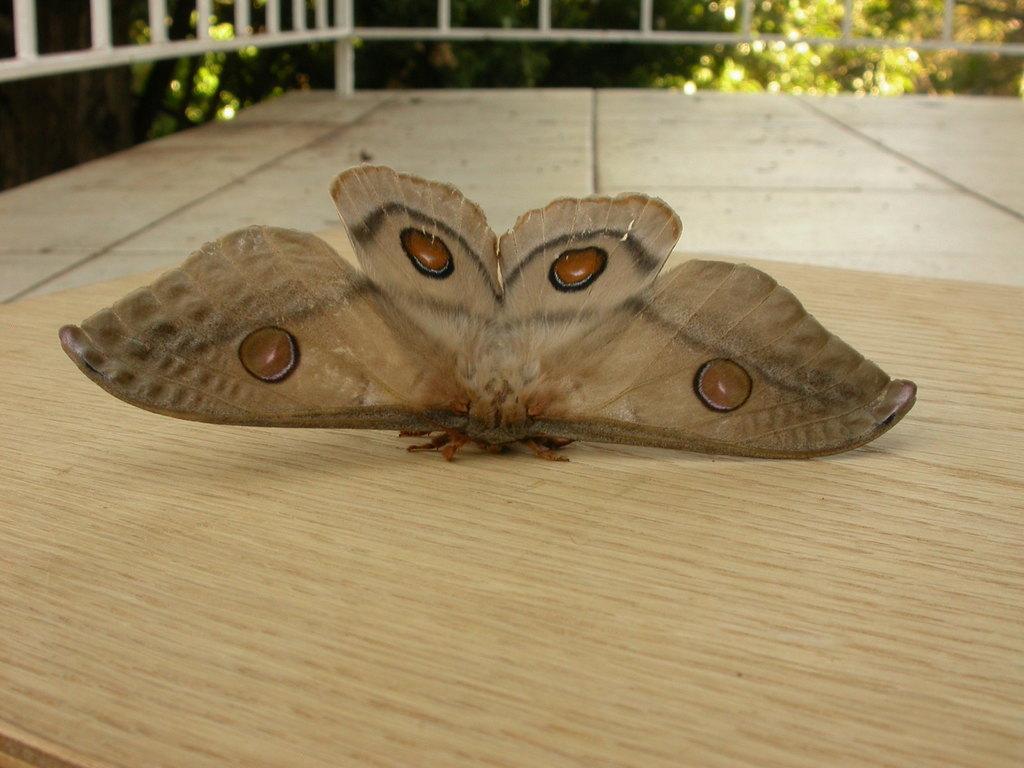Could you give a brief overview of what you see in this image? In this picture we can see a moth here, in the background there are some plants. 